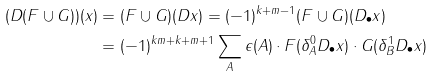Convert formula to latex. <formula><loc_0><loc_0><loc_500><loc_500>( D ( F \cup G ) ) ( x ) & = ( F \cup G ) ( D x ) = ( - 1 ) ^ { k + m - 1 } ( F \cup G ) ( D _ { \bullet } x ) \\ & = ( - 1 ) ^ { k m + k + m + 1 } \sum _ { A } \epsilon ( A ) \cdot F ( \delta ^ { 0 } _ { A } D _ { \bullet } x ) \cdot G ( \delta ^ { 1 } _ { B } D _ { \bullet } x )</formula> 